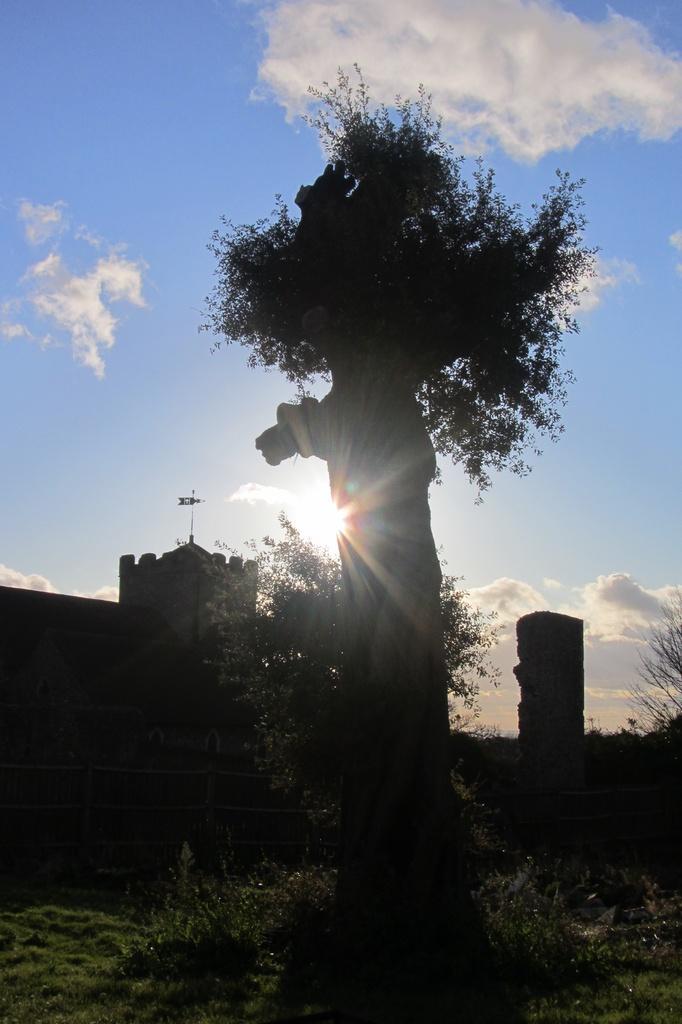Could you give a brief overview of what you see in this image? In this picture I can see many trees, plants and grass. In the background I can see the monuments. At the top of the monument there is a flag. At the top I can see the sky and clouds. Behind this tree I can see the sun. 